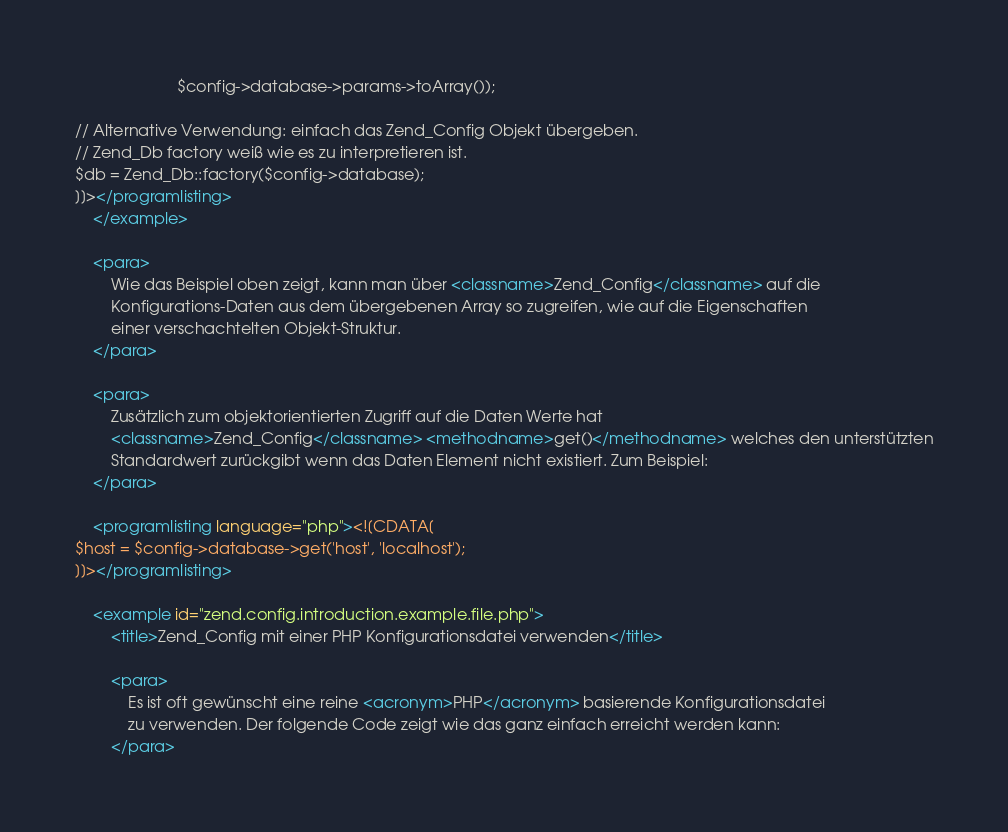<code> <loc_0><loc_0><loc_500><loc_500><_XML_>                       $config->database->params->toArray());

// Alternative Verwendung: einfach das Zend_Config Objekt übergeben.
// Zend_Db factory weiß wie es zu interpretieren ist.
$db = Zend_Db::factory($config->database);
]]></programlisting>
    </example>

    <para>
        Wie das Beispiel oben zeigt, kann man über <classname>Zend_Config</classname> auf die
        Konfigurations-Daten aus dem übergebenen Array so zugreifen, wie auf die Eigenschaften
        einer verschachtelten Objekt-Struktur.
    </para>

    <para>
        Zusätzlich zum objektorientierten Zugriff auf die Daten Werte hat
        <classname>Zend_Config</classname> <methodname>get()</methodname> welches den unterstützten
        Standardwert zurückgibt wenn das Daten Element nicht existiert. Zum Beispiel:
    </para>

    <programlisting language="php"><![CDATA[
$host = $config->database->get('host', 'localhost');
]]></programlisting>

    <example id="zend.config.introduction.example.file.php">
        <title>Zend_Config mit einer PHP Konfigurationsdatei verwenden</title>

        <para>
            Es ist oft gewünscht eine reine <acronym>PHP</acronym> basierende Konfigurationsdatei
            zu verwenden. Der folgende Code zeigt wie das ganz einfach erreicht werden kann:
        </para>
</code> 